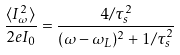Convert formula to latex. <formula><loc_0><loc_0><loc_500><loc_500>\frac { \langle I ^ { 2 } _ { \omega } \rangle } { 2 e I _ { 0 } } = \frac { 4 / \tau _ { s } ^ { 2 } } { ( \omega - \omega _ { L } ) ^ { 2 } + 1 / \tau _ { s } ^ { 2 } }</formula> 